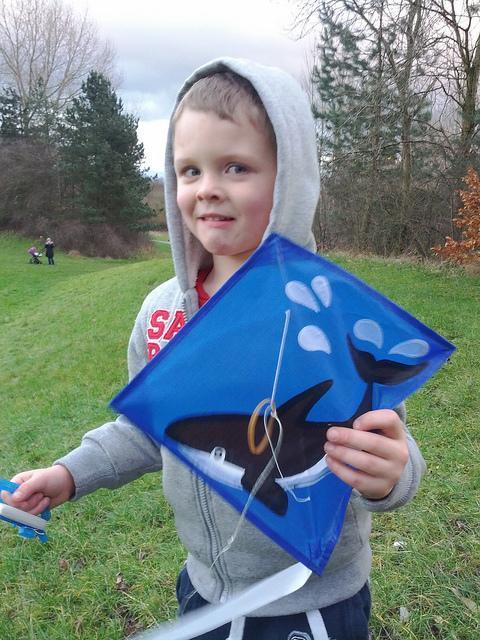How many wings does the airplane have?
Give a very brief answer. 0. 